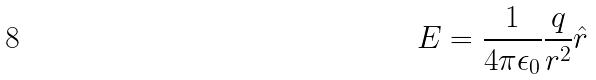Convert formula to latex. <formula><loc_0><loc_0><loc_500><loc_500>E = \frac { 1 } { 4 \pi \epsilon _ { 0 } } \frac { q } { r ^ { 2 } } \hat { r }</formula> 